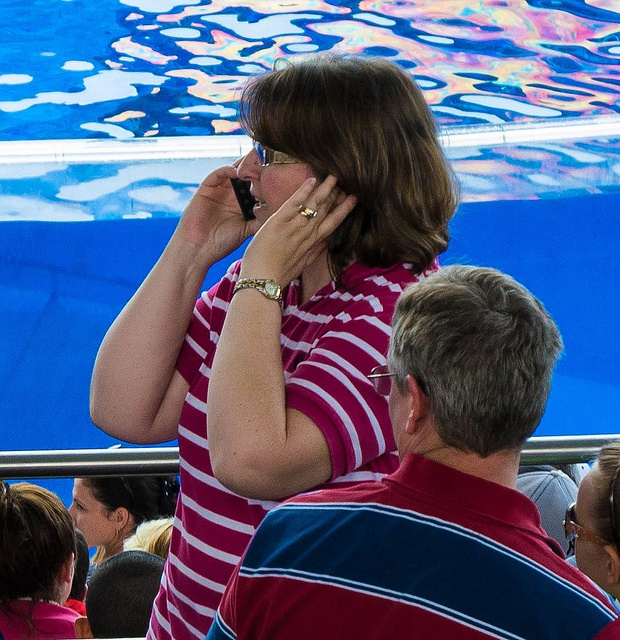Describe the objects in this image and their specific colors. I can see people in gray, black, and purple tones, people in gray, black, maroon, and navy tones, people in gray, black, and maroon tones, people in gray, black, brown, and maroon tones, and people in gray, black, white, and purple tones in this image. 